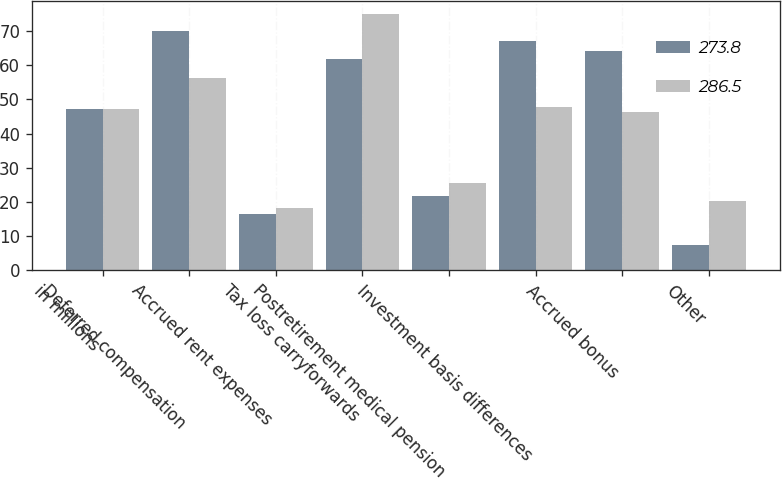Convert chart to OTSL. <chart><loc_0><loc_0><loc_500><loc_500><stacked_bar_chart><ecel><fcel>in millions<fcel>Deferred compensation<fcel>Accrued rent expenses<fcel>Tax loss carryforwards<fcel>Postretirement medical pension<fcel>Investment basis differences<fcel>Accrued bonus<fcel>Other<nl><fcel>273.8<fcel>47.05<fcel>70<fcel>16.4<fcel>61.7<fcel>21.7<fcel>67<fcel>64.1<fcel>7.3<nl><fcel>286.5<fcel>47.05<fcel>56.2<fcel>18.3<fcel>75<fcel>25.5<fcel>47.8<fcel>46.3<fcel>20.3<nl></chart> 